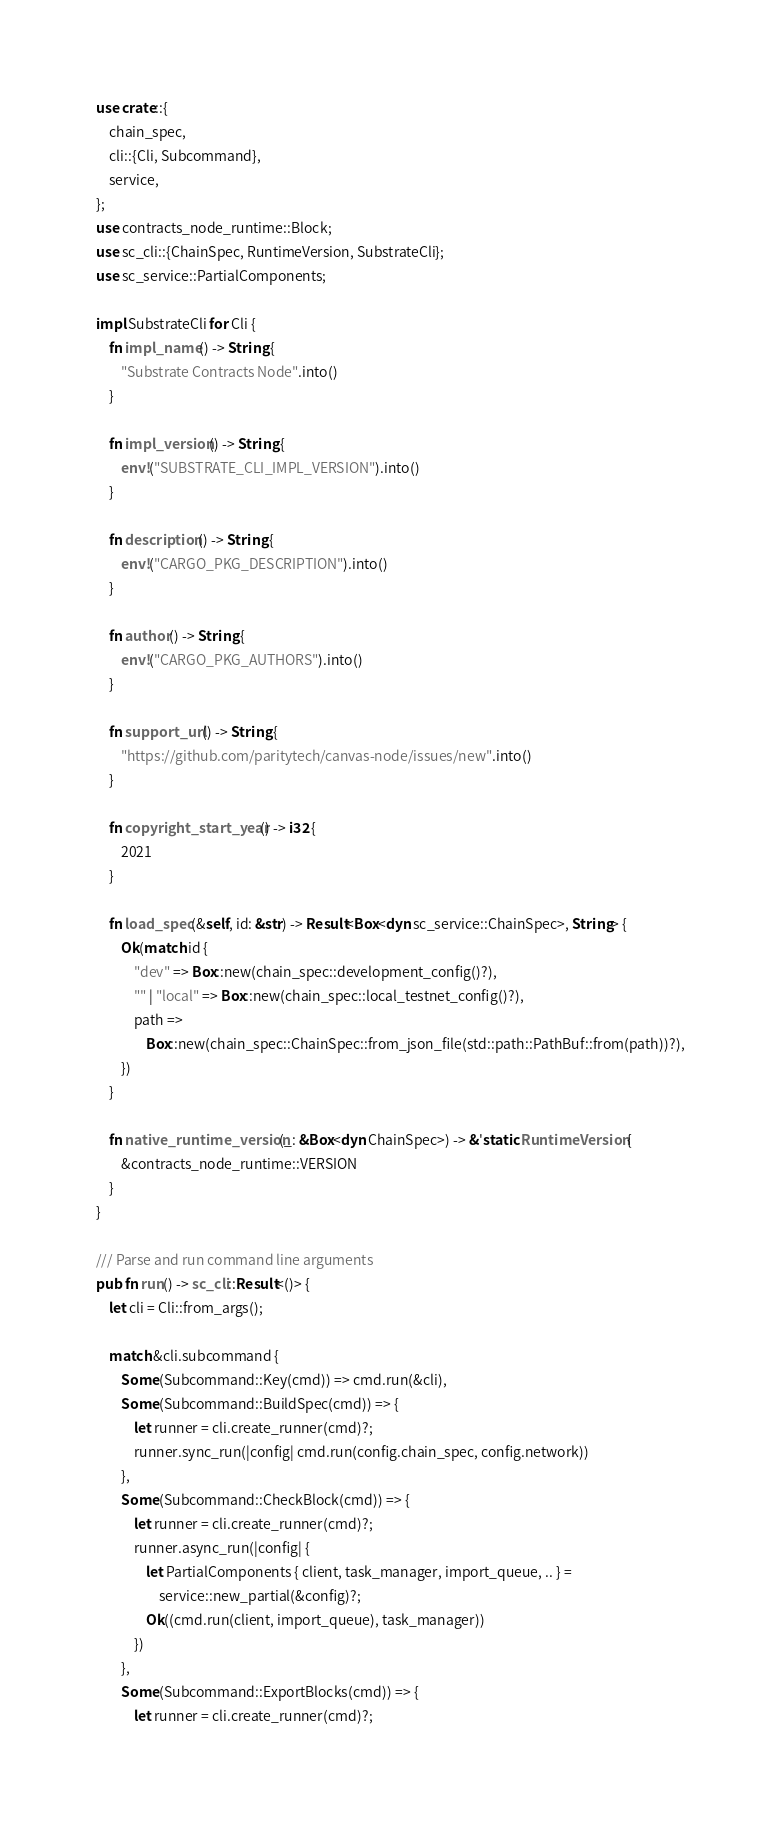Convert code to text. <code><loc_0><loc_0><loc_500><loc_500><_Rust_>use crate::{
	chain_spec,
	cli::{Cli, Subcommand},
	service,
};
use contracts_node_runtime::Block;
use sc_cli::{ChainSpec, RuntimeVersion, SubstrateCli};
use sc_service::PartialComponents;

impl SubstrateCli for Cli {
	fn impl_name() -> String {
		"Substrate Contracts Node".into()
	}

	fn impl_version() -> String {
		env!("SUBSTRATE_CLI_IMPL_VERSION").into()
	}

	fn description() -> String {
		env!("CARGO_PKG_DESCRIPTION").into()
	}

	fn author() -> String {
		env!("CARGO_PKG_AUTHORS").into()
	}

	fn support_url() -> String {
		"https://github.com/paritytech/canvas-node/issues/new".into()
	}

	fn copyright_start_year() -> i32 {
		2021
	}

	fn load_spec(&self, id: &str) -> Result<Box<dyn sc_service::ChainSpec>, String> {
		Ok(match id {
			"dev" => Box::new(chain_spec::development_config()?),
			"" | "local" => Box::new(chain_spec::local_testnet_config()?),
			path =>
				Box::new(chain_spec::ChainSpec::from_json_file(std::path::PathBuf::from(path))?),
		})
	}

	fn native_runtime_version(_: &Box<dyn ChainSpec>) -> &'static RuntimeVersion {
		&contracts_node_runtime::VERSION
	}
}

/// Parse and run command line arguments
pub fn run() -> sc_cli::Result<()> {
	let cli = Cli::from_args();

	match &cli.subcommand {
		Some(Subcommand::Key(cmd)) => cmd.run(&cli),
		Some(Subcommand::BuildSpec(cmd)) => {
			let runner = cli.create_runner(cmd)?;
			runner.sync_run(|config| cmd.run(config.chain_spec, config.network))
		},
		Some(Subcommand::CheckBlock(cmd)) => {
			let runner = cli.create_runner(cmd)?;
			runner.async_run(|config| {
				let PartialComponents { client, task_manager, import_queue, .. } =
					service::new_partial(&config)?;
				Ok((cmd.run(client, import_queue), task_manager))
			})
		},
		Some(Subcommand::ExportBlocks(cmd)) => {
			let runner = cli.create_runner(cmd)?;</code> 